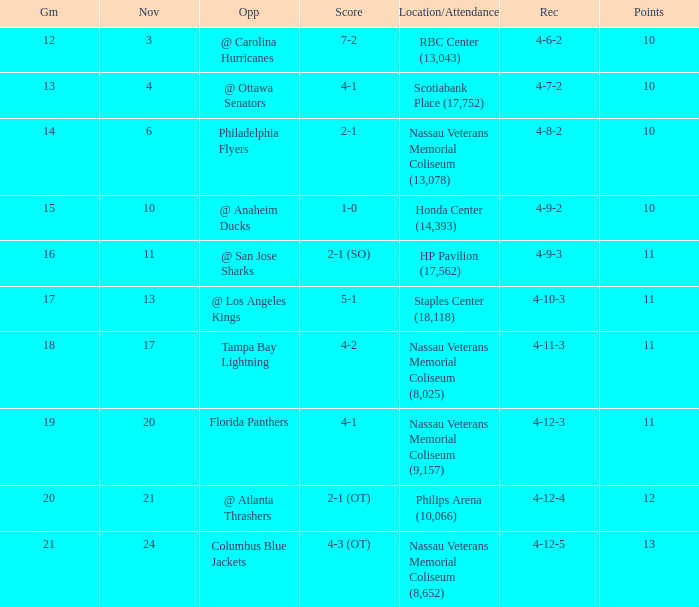What is the highest entry in November for the game 20? 21.0. 